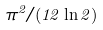Convert formula to latex. <formula><loc_0><loc_0><loc_500><loc_500>\pi ^ { 2 } / ( 1 2 \ln 2 )</formula> 